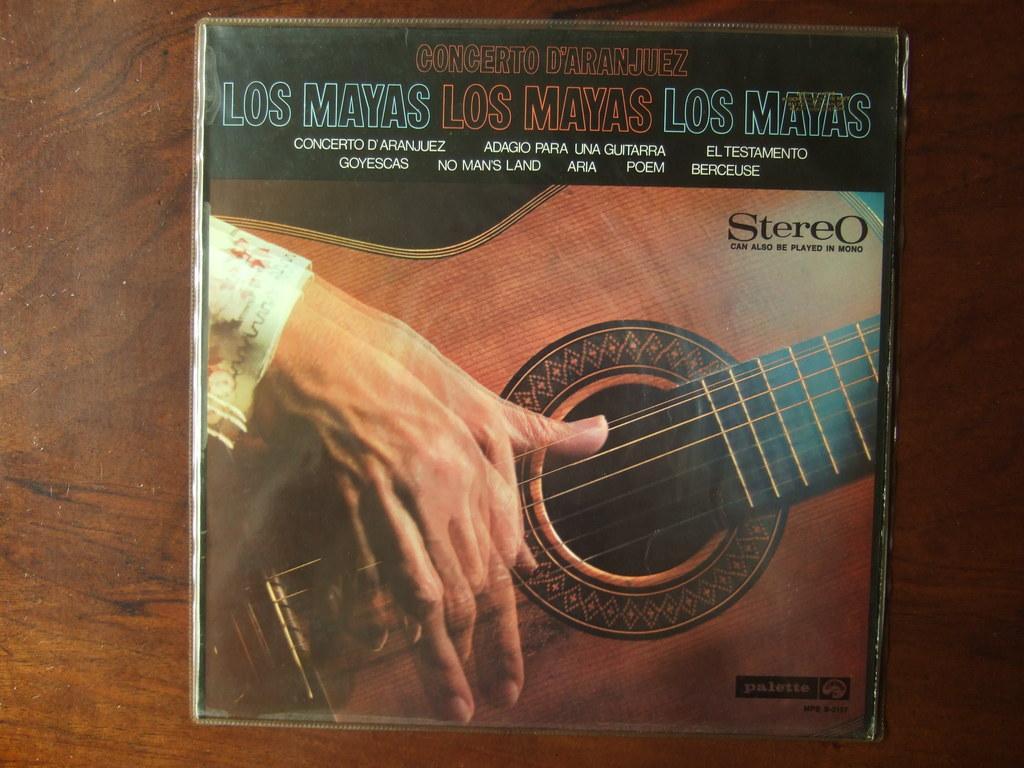Can you describe this image briefly? In this picture we can observe a guitar which is in brown color on the box. There is a human hand on the guitar. We can observe blue and orange color words on this box. This box is placed on the brown color table. 